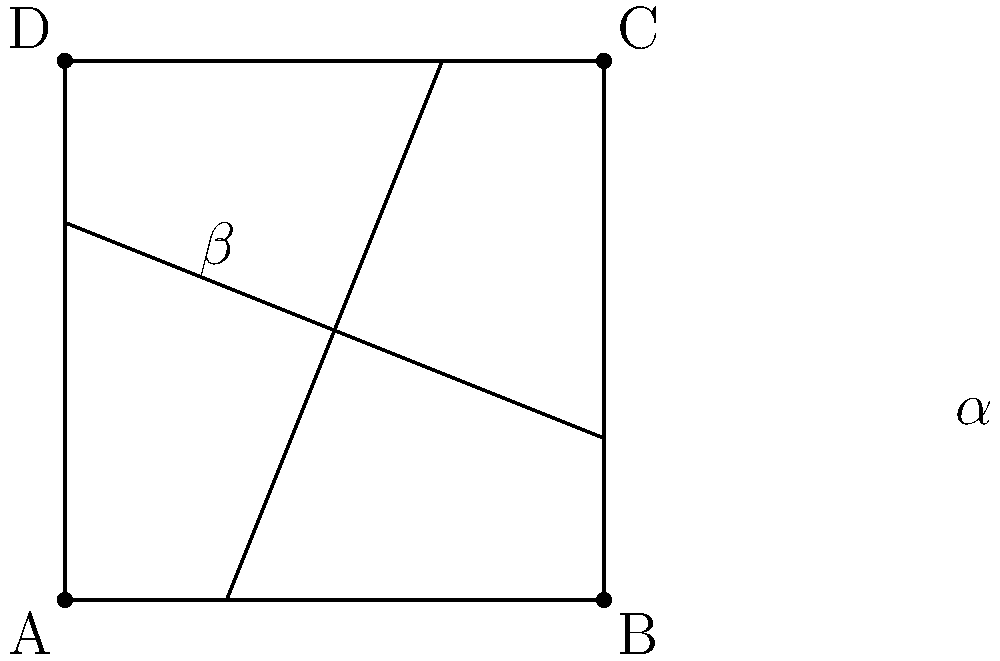In the ancient grid system of Alexandria, two major streets intersect as shown in the diagram. If the angle $\alpha$ formed by one street with the horizontal is 30°, what is the measure of angle $\beta$? To solve this problem, let's follow these steps:

1) First, recall that when two straight lines intersect, they form four angles. The angles opposite each other (called vertical angles) are always congruent.

2) In our diagram, $\alpha$ and $\beta$ are vertical angles, so they are congruent:

   $\alpha = \beta$

3) We're given that $\alpha = 30°$, so:

   $\beta = 30°$

4) However, we need to verify if this is the angle being asked for. In a rectangular grid system, streets typically intersect at right angles (90°).

5) The angle $\beta$ in the diagram is the complement of the angle formed by the street with the vertical. If we call this complement $\beta'$, then:

   $\beta + \beta' = 90°$

6) Since $\beta = 30°$, we can find $\beta'$:

   $30° + \beta' = 90°$
   $\beta' = 60°$

7) The question is asking for the angle formed with the vertical, which is $\beta'$, not $\beta$.

Therefore, the measure of the angle $\beta$ shown in the diagram is 60°.
Answer: 60° 